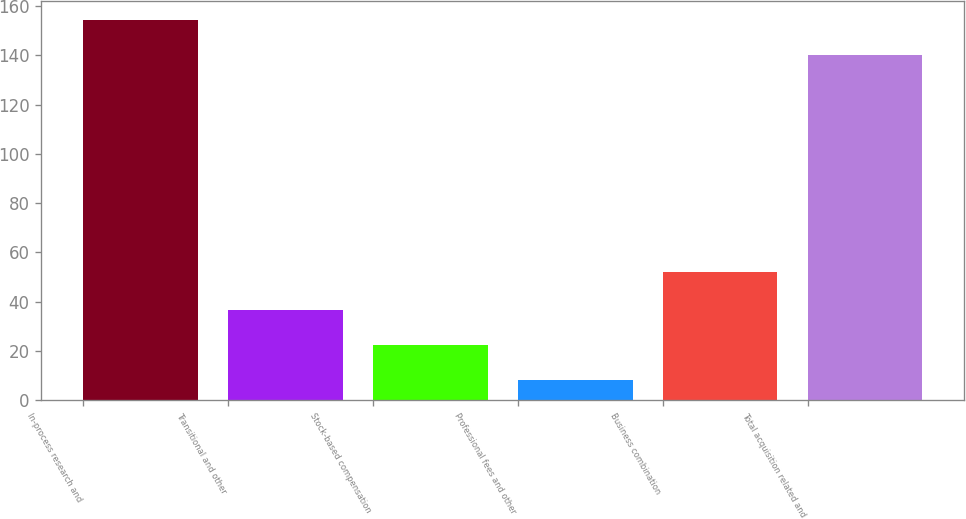<chart> <loc_0><loc_0><loc_500><loc_500><bar_chart><fcel>In-process research and<fcel>Transitional and other<fcel>Stock-based compensation<fcel>Professional fees and other<fcel>Business combination<fcel>Total acquisition related and<nl><fcel>154.3<fcel>36.6<fcel>22.3<fcel>8<fcel>52<fcel>140<nl></chart> 